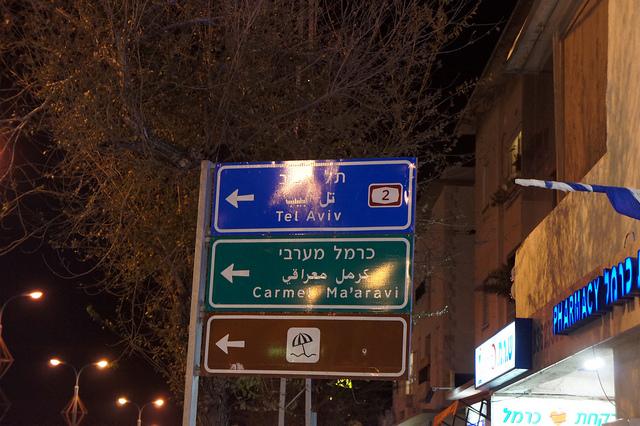What is making the street signs appear so bright?
Answer briefly. Lights. Can you make out the numbers on the train?
Short answer required. No. Where is this located?
Be succinct. Israel. How many signs are there?
Keep it brief. 3. What does the red sign say?
Concise answer only. 2. What city is mentioned in the top sign?
Short answer required. Tel aviv. Was this photo taken during the day?
Give a very brief answer. No. What does PRIMACY mean?
Write a very short answer. Pharmacy. Is this in Israel?
Short answer required. Yes. 